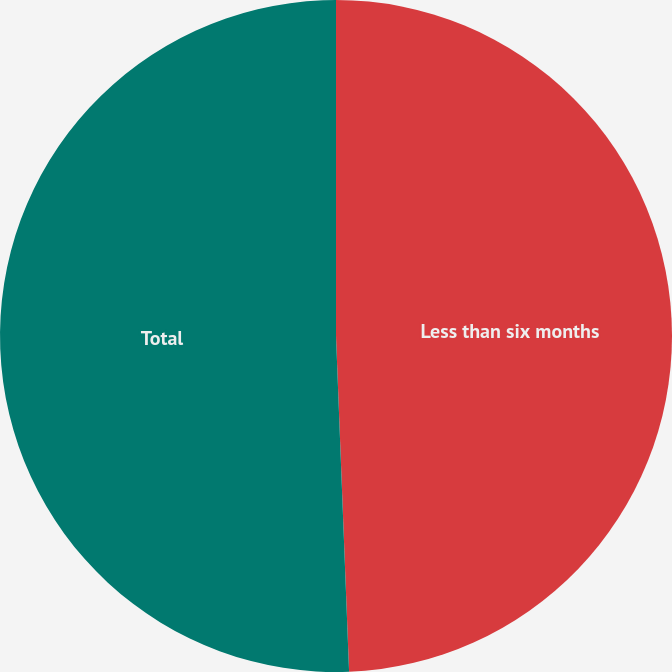Convert chart. <chart><loc_0><loc_0><loc_500><loc_500><pie_chart><fcel>Less than six months<fcel>Total<nl><fcel>49.38%<fcel>50.62%<nl></chart> 